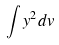<formula> <loc_0><loc_0><loc_500><loc_500>\int y ^ { 2 } d v</formula> 